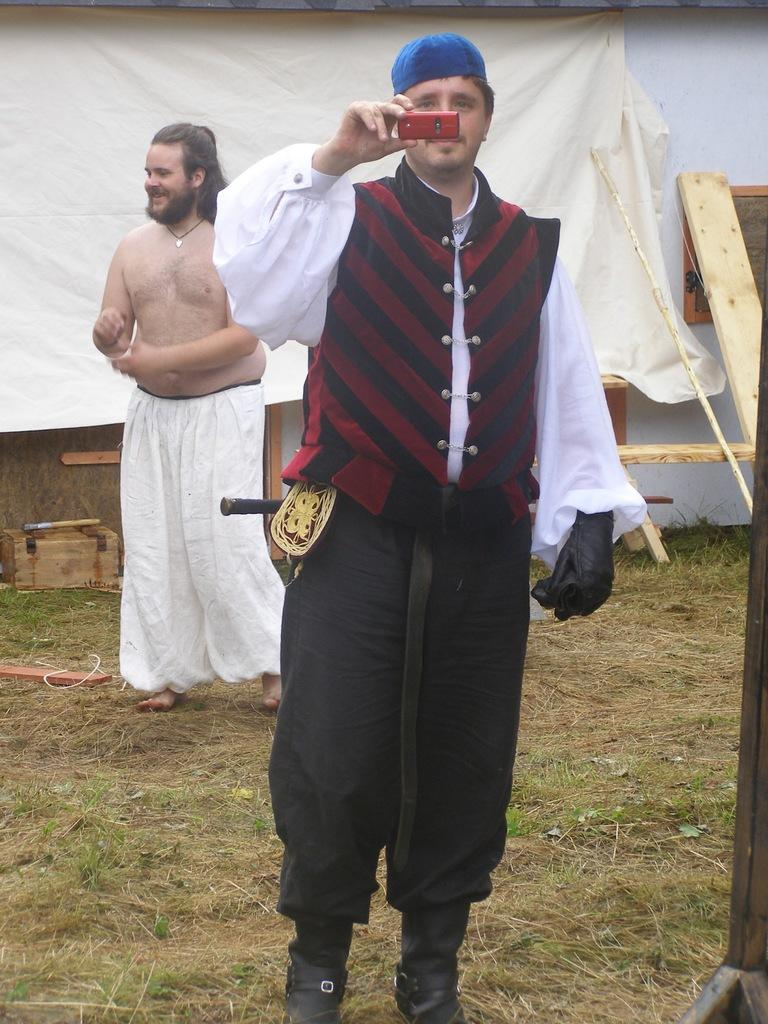What is the main subject of the image? There is a person standing in the image. What is the person holding in his hand? The person is holding a mobile in his hand. Can you describe the position of the second person in the image? There is another person standing behind the first person. What else can be seen in the background of the image? There are other objects in the background of the image. How many ladybugs can be seen crawling on the mobile in the image? There are no ladybugs present in the image. What type of distribution system is being used by the bears in the image? There are no bears present in the image. 